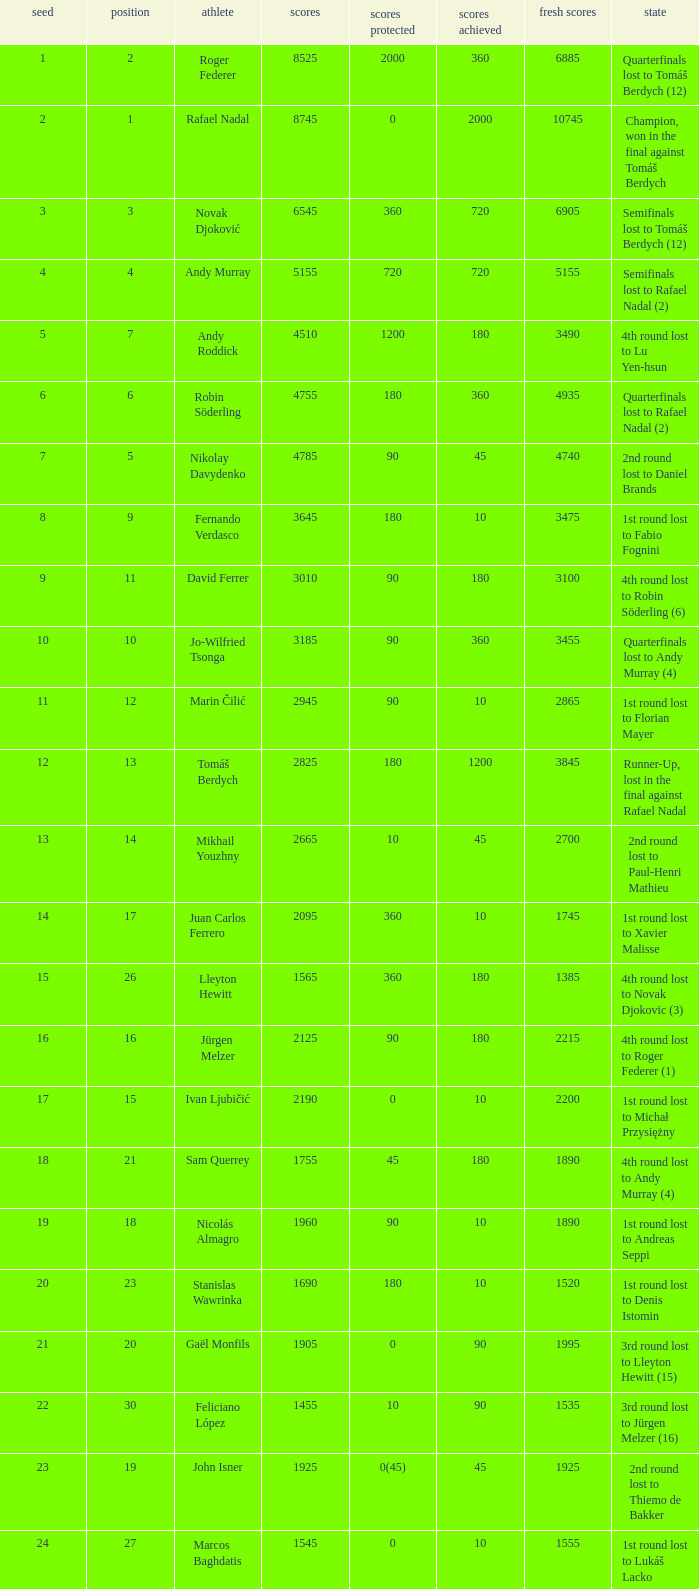Name the points won for 1230 90.0. 